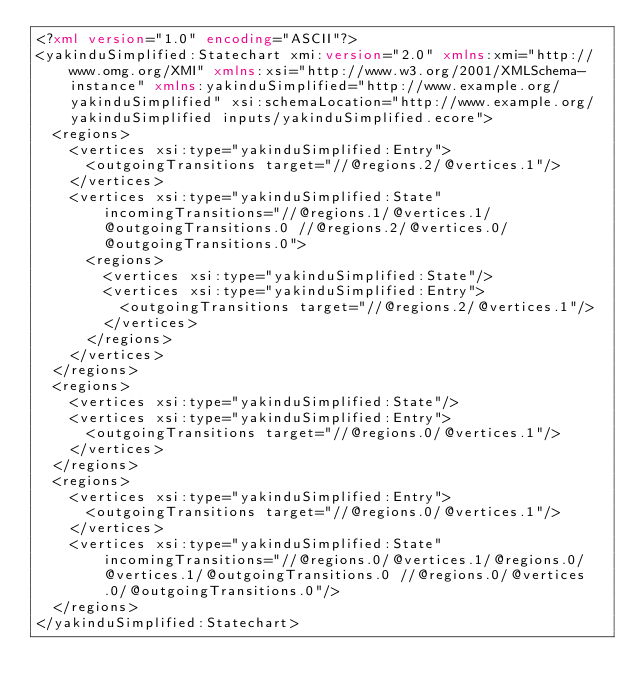<code> <loc_0><loc_0><loc_500><loc_500><_XML_><?xml version="1.0" encoding="ASCII"?>
<yakinduSimplified:Statechart xmi:version="2.0" xmlns:xmi="http://www.omg.org/XMI" xmlns:xsi="http://www.w3.org/2001/XMLSchema-instance" xmlns:yakinduSimplified="http://www.example.org/yakinduSimplified" xsi:schemaLocation="http://www.example.org/yakinduSimplified inputs/yakinduSimplified.ecore">
  <regions>
    <vertices xsi:type="yakinduSimplified:Entry">
      <outgoingTransitions target="//@regions.2/@vertices.1"/>
    </vertices>
    <vertices xsi:type="yakinduSimplified:State" incomingTransitions="//@regions.1/@vertices.1/@outgoingTransitions.0 //@regions.2/@vertices.0/@outgoingTransitions.0">
      <regions>
        <vertices xsi:type="yakinduSimplified:State"/>
        <vertices xsi:type="yakinduSimplified:Entry">
          <outgoingTransitions target="//@regions.2/@vertices.1"/>
        </vertices>
      </regions>
    </vertices>
  </regions>
  <regions>
    <vertices xsi:type="yakinduSimplified:State"/>
    <vertices xsi:type="yakinduSimplified:Entry">
      <outgoingTransitions target="//@regions.0/@vertices.1"/>
    </vertices>
  </regions>
  <regions>
    <vertices xsi:type="yakinduSimplified:Entry">
      <outgoingTransitions target="//@regions.0/@vertices.1"/>
    </vertices>
    <vertices xsi:type="yakinduSimplified:State" incomingTransitions="//@regions.0/@vertices.1/@regions.0/@vertices.1/@outgoingTransitions.0 //@regions.0/@vertices.0/@outgoingTransitions.0"/>
  </regions>
</yakinduSimplified:Statechart>
</code> 